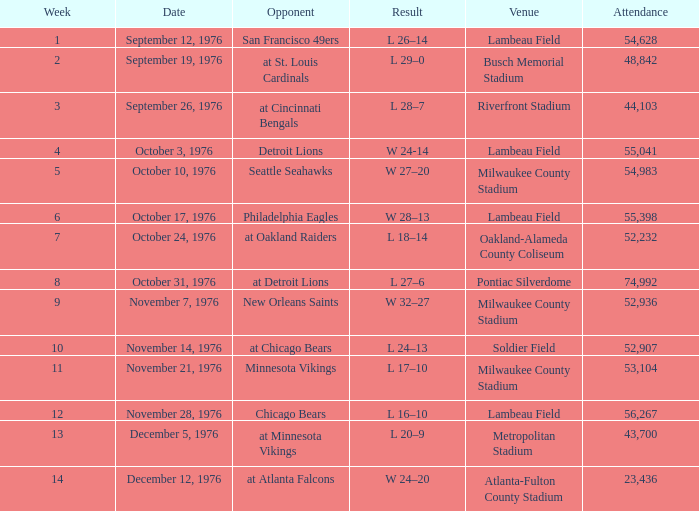What is the least week number when they played against the detroit lions? 4.0. 